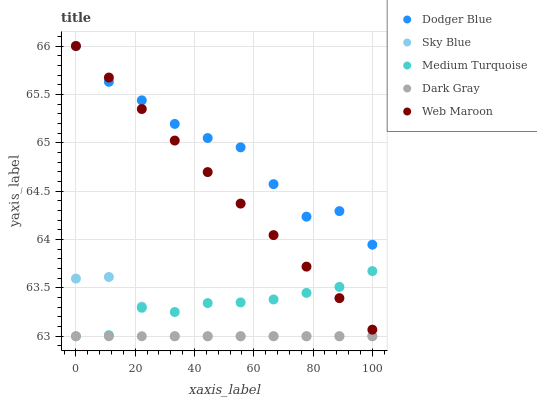Does Dark Gray have the minimum area under the curve?
Answer yes or no. Yes. Does Dodger Blue have the maximum area under the curve?
Answer yes or no. Yes. Does Sky Blue have the minimum area under the curve?
Answer yes or no. No. Does Sky Blue have the maximum area under the curve?
Answer yes or no. No. Is Dark Gray the smoothest?
Answer yes or no. Yes. Is Dodger Blue the roughest?
Answer yes or no. Yes. Is Sky Blue the smoothest?
Answer yes or no. No. Is Sky Blue the roughest?
Answer yes or no. No. Does Dark Gray have the lowest value?
Answer yes or no. Yes. Does Dodger Blue have the lowest value?
Answer yes or no. No. Does Web Maroon have the highest value?
Answer yes or no. Yes. Does Sky Blue have the highest value?
Answer yes or no. No. Is Sky Blue less than Dodger Blue?
Answer yes or no. Yes. Is Dodger Blue greater than Sky Blue?
Answer yes or no. Yes. Does Sky Blue intersect Dark Gray?
Answer yes or no. Yes. Is Sky Blue less than Dark Gray?
Answer yes or no. No. Is Sky Blue greater than Dark Gray?
Answer yes or no. No. Does Sky Blue intersect Dodger Blue?
Answer yes or no. No. 